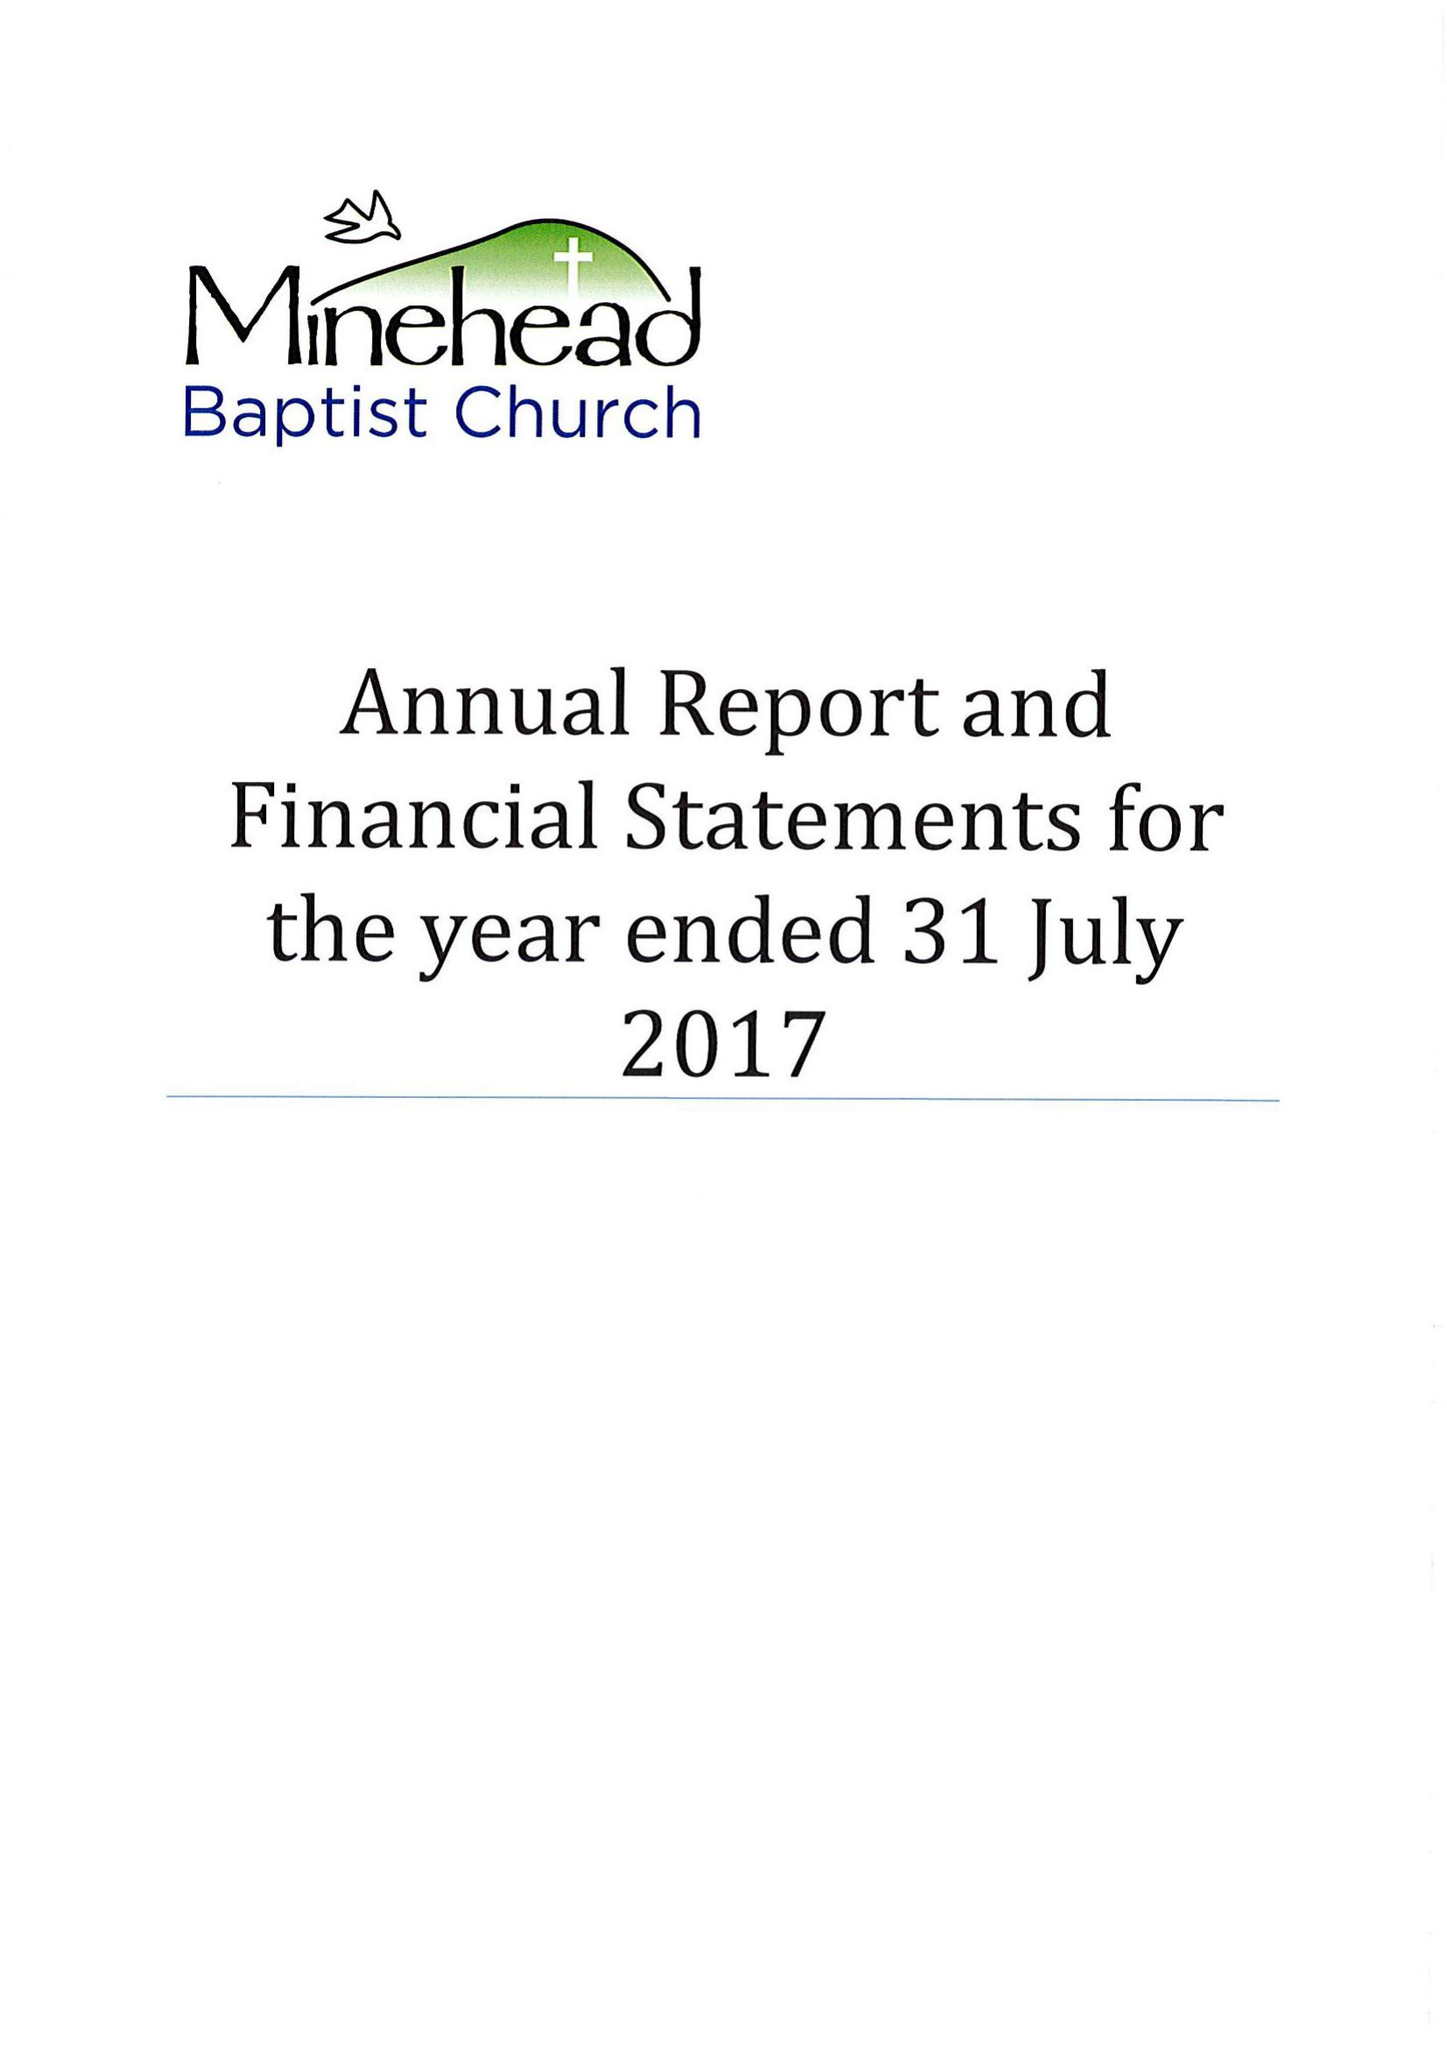What is the value for the charity_number?
Answer the question using a single word or phrase. 1130521 